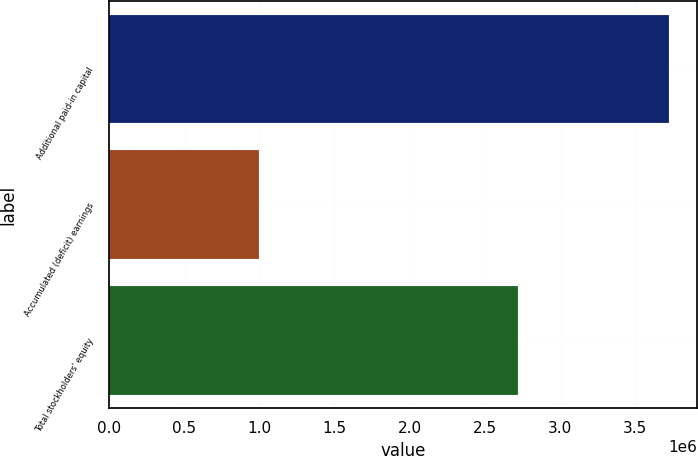<chart> <loc_0><loc_0><loc_500><loc_500><bar_chart><fcel>Additional paid-in capital<fcel>Accumulated (deficit) earnings<fcel>Total stockholders' equity<nl><fcel>3.72695e+06<fcel>999976<fcel>2.72141e+06<nl></chart> 